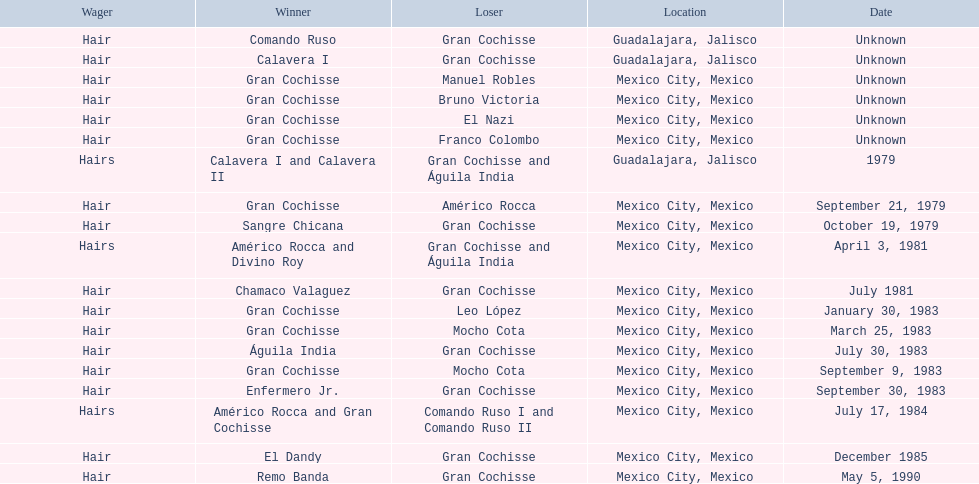Could you help me parse every detail presented in this table? {'header': ['Wager', 'Winner', 'Loser', 'Location', 'Date'], 'rows': [['Hair', 'Comando Ruso', 'Gran Cochisse', 'Guadalajara, Jalisco', 'Unknown'], ['Hair', 'Calavera I', 'Gran Cochisse', 'Guadalajara, Jalisco', 'Unknown'], ['Hair', 'Gran Cochisse', 'Manuel Robles', 'Mexico City, Mexico', 'Unknown'], ['Hair', 'Gran Cochisse', 'Bruno Victoria', 'Mexico City, Mexico', 'Unknown'], ['Hair', 'Gran Cochisse', 'El Nazi', 'Mexico City, Mexico', 'Unknown'], ['Hair', 'Gran Cochisse', 'Franco Colombo', 'Mexico City, Mexico', 'Unknown'], ['Hairs', 'Calavera I and Calavera II', 'Gran Cochisse and Águila India', 'Guadalajara, Jalisco', '1979'], ['Hair', 'Gran Cochisse', 'Américo Rocca', 'Mexico City, Mexico', 'September 21, 1979'], ['Hair', 'Sangre Chicana', 'Gran Cochisse', 'Mexico City, Mexico', 'October 19, 1979'], ['Hairs', 'Américo Rocca and Divino Roy', 'Gran Cochisse and Águila India', 'Mexico City, Mexico', 'April 3, 1981'], ['Hair', 'Chamaco Valaguez', 'Gran Cochisse', 'Mexico City, Mexico', 'July 1981'], ['Hair', 'Gran Cochisse', 'Leo López', 'Mexico City, Mexico', 'January 30, 1983'], ['Hair', 'Gran Cochisse', 'Mocho Cota', 'Mexico City, Mexico', 'March 25, 1983'], ['Hair', 'Águila India', 'Gran Cochisse', 'Mexico City, Mexico', 'July 30, 1983'], ['Hair', 'Gran Cochisse', 'Mocho Cota', 'Mexico City, Mexico', 'September 9, 1983'], ['Hair', 'Enfermero Jr.', 'Gran Cochisse', 'Mexico City, Mexico', 'September 30, 1983'], ['Hairs', 'Américo Rocca and Gran Cochisse', 'Comando Ruso I and Comando Ruso II', 'Mexico City, Mexico', 'July 17, 1984'], ['Hair', 'El Dandy', 'Gran Cochisse', 'Mexico City, Mexico', 'December 1985'], ['Hair', 'Remo Banda', 'Gran Cochisse', 'Mexico City, Mexico', 'May 5, 1990']]} How many winners were there before bruno victoria lost? 3. 